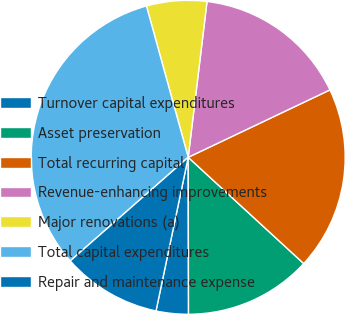<chart> <loc_0><loc_0><loc_500><loc_500><pie_chart><fcel>Turnover capital expenditures<fcel>Asset preservation<fcel>Total recurring capital<fcel>Revenue-enhancing improvements<fcel>Major renovations (a)<fcel>Total capital expenditures<fcel>Repair and maintenance expense<nl><fcel>3.32%<fcel>13.13%<fcel>18.9%<fcel>16.02%<fcel>6.2%<fcel>32.18%<fcel>10.24%<nl></chart> 